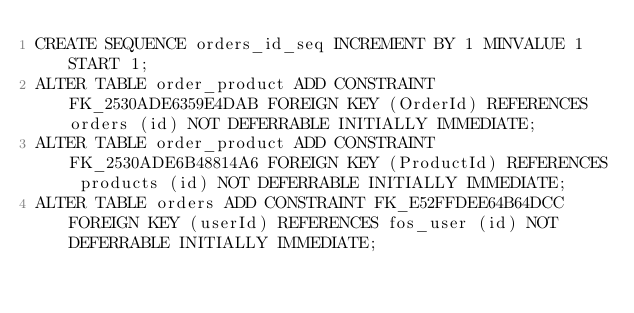Convert code to text. <code><loc_0><loc_0><loc_500><loc_500><_SQL_>CREATE SEQUENCE orders_id_seq INCREMENT BY 1 MINVALUE 1 START 1;
ALTER TABLE order_product ADD CONSTRAINT FK_2530ADE6359E4DAB FOREIGN KEY (OrderId) REFERENCES orders (id) NOT DEFERRABLE INITIALLY IMMEDIATE;
ALTER TABLE order_product ADD CONSTRAINT FK_2530ADE6B48814A6 FOREIGN KEY (ProductId) REFERENCES products (id) NOT DEFERRABLE INITIALLY IMMEDIATE;
ALTER TABLE orders ADD CONSTRAINT FK_E52FFDEE64B64DCC FOREIGN KEY (userId) REFERENCES fos_user (id) NOT DEFERRABLE INITIALLY IMMEDIATE;
</code> 